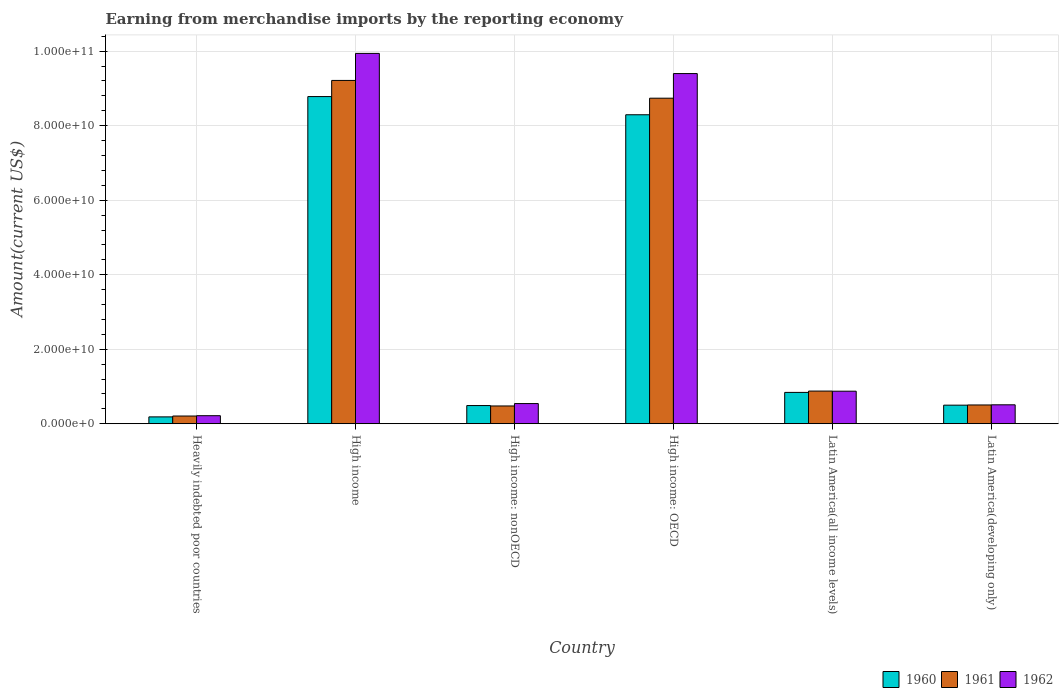How many different coloured bars are there?
Provide a succinct answer. 3. Are the number of bars per tick equal to the number of legend labels?
Offer a very short reply. Yes. Are the number of bars on each tick of the X-axis equal?
Your response must be concise. Yes. How many bars are there on the 5th tick from the right?
Your answer should be compact. 3. What is the label of the 3rd group of bars from the left?
Offer a very short reply. High income: nonOECD. In how many cases, is the number of bars for a given country not equal to the number of legend labels?
Your answer should be very brief. 0. What is the amount earned from merchandise imports in 1960 in High income: nonOECD?
Offer a terse response. 4.88e+09. Across all countries, what is the maximum amount earned from merchandise imports in 1961?
Your answer should be compact. 9.21e+1. Across all countries, what is the minimum amount earned from merchandise imports in 1962?
Offer a very short reply. 2.16e+09. In which country was the amount earned from merchandise imports in 1961 maximum?
Your response must be concise. High income. In which country was the amount earned from merchandise imports in 1961 minimum?
Your response must be concise. Heavily indebted poor countries. What is the total amount earned from merchandise imports in 1961 in the graph?
Your answer should be very brief. 2.00e+11. What is the difference between the amount earned from merchandise imports in 1962 in High income and that in High income: OECD?
Your answer should be very brief. 5.41e+09. What is the difference between the amount earned from merchandise imports in 1962 in Latin America(developing only) and the amount earned from merchandise imports in 1960 in High income: OECD?
Your answer should be compact. -7.78e+1. What is the average amount earned from merchandise imports in 1962 per country?
Your answer should be compact. 3.58e+1. What is the difference between the amount earned from merchandise imports of/in 1961 and amount earned from merchandise imports of/in 1960 in High income?
Offer a very short reply. 4.34e+09. In how many countries, is the amount earned from merchandise imports in 1960 greater than 28000000000 US$?
Your answer should be compact. 2. What is the ratio of the amount earned from merchandise imports in 1961 in High income to that in High income: OECD?
Your answer should be very brief. 1.05. Is the amount earned from merchandise imports in 1960 in High income less than that in High income: nonOECD?
Make the answer very short. No. Is the difference between the amount earned from merchandise imports in 1961 in Heavily indebted poor countries and High income: nonOECD greater than the difference between the amount earned from merchandise imports in 1960 in Heavily indebted poor countries and High income: nonOECD?
Offer a very short reply. Yes. What is the difference between the highest and the second highest amount earned from merchandise imports in 1961?
Keep it short and to the point. 8.34e+1. What is the difference between the highest and the lowest amount earned from merchandise imports in 1960?
Make the answer very short. 8.60e+1. In how many countries, is the amount earned from merchandise imports in 1962 greater than the average amount earned from merchandise imports in 1962 taken over all countries?
Provide a succinct answer. 2. Is the sum of the amount earned from merchandise imports in 1961 in High income and Latin America(all income levels) greater than the maximum amount earned from merchandise imports in 1962 across all countries?
Make the answer very short. Yes. What does the 2nd bar from the right in High income represents?
Your answer should be compact. 1961. Is it the case that in every country, the sum of the amount earned from merchandise imports in 1961 and amount earned from merchandise imports in 1962 is greater than the amount earned from merchandise imports in 1960?
Your response must be concise. Yes. How many bars are there?
Offer a very short reply. 18. What is the difference between two consecutive major ticks on the Y-axis?
Provide a succinct answer. 2.00e+1. Does the graph contain any zero values?
Your answer should be compact. No. What is the title of the graph?
Your response must be concise. Earning from merchandise imports by the reporting economy. Does "1997" appear as one of the legend labels in the graph?
Keep it short and to the point. No. What is the label or title of the X-axis?
Provide a succinct answer. Country. What is the label or title of the Y-axis?
Give a very brief answer. Amount(current US$). What is the Amount(current US$) of 1960 in Heavily indebted poor countries?
Offer a terse response. 1.84e+09. What is the Amount(current US$) of 1961 in Heavily indebted poor countries?
Your answer should be compact. 2.07e+09. What is the Amount(current US$) in 1962 in Heavily indebted poor countries?
Provide a succinct answer. 2.16e+09. What is the Amount(current US$) of 1960 in High income?
Keep it short and to the point. 8.78e+1. What is the Amount(current US$) in 1961 in High income?
Keep it short and to the point. 9.21e+1. What is the Amount(current US$) of 1962 in High income?
Offer a very short reply. 9.94e+1. What is the Amount(current US$) of 1960 in High income: nonOECD?
Your answer should be compact. 4.88e+09. What is the Amount(current US$) in 1961 in High income: nonOECD?
Offer a terse response. 4.77e+09. What is the Amount(current US$) of 1962 in High income: nonOECD?
Offer a very short reply. 5.41e+09. What is the Amount(current US$) in 1960 in High income: OECD?
Your answer should be very brief. 8.29e+1. What is the Amount(current US$) of 1961 in High income: OECD?
Ensure brevity in your answer.  8.74e+1. What is the Amount(current US$) of 1962 in High income: OECD?
Your answer should be very brief. 9.40e+1. What is the Amount(current US$) in 1960 in Latin America(all income levels)?
Your answer should be compact. 8.41e+09. What is the Amount(current US$) in 1961 in Latin America(all income levels)?
Your response must be concise. 8.77e+09. What is the Amount(current US$) of 1962 in Latin America(all income levels)?
Your response must be concise. 8.73e+09. What is the Amount(current US$) of 1960 in Latin America(developing only)?
Ensure brevity in your answer.  4.99e+09. What is the Amount(current US$) in 1961 in Latin America(developing only)?
Provide a short and direct response. 5.04e+09. What is the Amount(current US$) of 1962 in Latin America(developing only)?
Your response must be concise. 5.08e+09. Across all countries, what is the maximum Amount(current US$) in 1960?
Ensure brevity in your answer.  8.78e+1. Across all countries, what is the maximum Amount(current US$) of 1961?
Ensure brevity in your answer.  9.21e+1. Across all countries, what is the maximum Amount(current US$) of 1962?
Your response must be concise. 9.94e+1. Across all countries, what is the minimum Amount(current US$) in 1960?
Provide a short and direct response. 1.84e+09. Across all countries, what is the minimum Amount(current US$) in 1961?
Offer a very short reply. 2.07e+09. Across all countries, what is the minimum Amount(current US$) in 1962?
Provide a succinct answer. 2.16e+09. What is the total Amount(current US$) of 1960 in the graph?
Make the answer very short. 1.91e+11. What is the total Amount(current US$) in 1961 in the graph?
Provide a succinct answer. 2.00e+11. What is the total Amount(current US$) of 1962 in the graph?
Make the answer very short. 2.15e+11. What is the difference between the Amount(current US$) in 1960 in Heavily indebted poor countries and that in High income?
Ensure brevity in your answer.  -8.60e+1. What is the difference between the Amount(current US$) of 1961 in Heavily indebted poor countries and that in High income?
Your response must be concise. -9.01e+1. What is the difference between the Amount(current US$) in 1962 in Heavily indebted poor countries and that in High income?
Provide a succinct answer. -9.72e+1. What is the difference between the Amount(current US$) in 1960 in Heavily indebted poor countries and that in High income: nonOECD?
Ensure brevity in your answer.  -3.04e+09. What is the difference between the Amount(current US$) of 1961 in Heavily indebted poor countries and that in High income: nonOECD?
Ensure brevity in your answer.  -2.70e+09. What is the difference between the Amount(current US$) in 1962 in Heavily indebted poor countries and that in High income: nonOECD?
Ensure brevity in your answer.  -3.25e+09. What is the difference between the Amount(current US$) in 1960 in Heavily indebted poor countries and that in High income: OECD?
Provide a succinct answer. -8.11e+1. What is the difference between the Amount(current US$) in 1961 in Heavily indebted poor countries and that in High income: OECD?
Give a very brief answer. -8.53e+1. What is the difference between the Amount(current US$) of 1962 in Heavily indebted poor countries and that in High income: OECD?
Keep it short and to the point. -9.18e+1. What is the difference between the Amount(current US$) of 1960 in Heavily indebted poor countries and that in Latin America(all income levels)?
Your answer should be very brief. -6.57e+09. What is the difference between the Amount(current US$) of 1961 in Heavily indebted poor countries and that in Latin America(all income levels)?
Your answer should be compact. -6.70e+09. What is the difference between the Amount(current US$) in 1962 in Heavily indebted poor countries and that in Latin America(all income levels)?
Keep it short and to the point. -6.57e+09. What is the difference between the Amount(current US$) in 1960 in Heavily indebted poor countries and that in Latin America(developing only)?
Ensure brevity in your answer.  -3.15e+09. What is the difference between the Amount(current US$) of 1961 in Heavily indebted poor countries and that in Latin America(developing only)?
Make the answer very short. -2.97e+09. What is the difference between the Amount(current US$) of 1962 in Heavily indebted poor countries and that in Latin America(developing only)?
Keep it short and to the point. -2.92e+09. What is the difference between the Amount(current US$) in 1960 in High income and that in High income: nonOECD?
Your response must be concise. 8.29e+1. What is the difference between the Amount(current US$) of 1961 in High income and that in High income: nonOECD?
Your response must be concise. 8.74e+1. What is the difference between the Amount(current US$) of 1962 in High income and that in High income: nonOECD?
Provide a succinct answer. 9.40e+1. What is the difference between the Amount(current US$) in 1960 in High income and that in High income: OECD?
Give a very brief answer. 4.88e+09. What is the difference between the Amount(current US$) of 1961 in High income and that in High income: OECD?
Offer a terse response. 4.77e+09. What is the difference between the Amount(current US$) of 1962 in High income and that in High income: OECD?
Keep it short and to the point. 5.41e+09. What is the difference between the Amount(current US$) in 1960 in High income and that in Latin America(all income levels)?
Offer a very short reply. 7.94e+1. What is the difference between the Amount(current US$) in 1961 in High income and that in Latin America(all income levels)?
Offer a very short reply. 8.34e+1. What is the difference between the Amount(current US$) in 1962 in High income and that in Latin America(all income levels)?
Make the answer very short. 9.07e+1. What is the difference between the Amount(current US$) in 1960 in High income and that in Latin America(developing only)?
Give a very brief answer. 8.28e+1. What is the difference between the Amount(current US$) in 1961 in High income and that in Latin America(developing only)?
Your answer should be very brief. 8.71e+1. What is the difference between the Amount(current US$) of 1962 in High income and that in Latin America(developing only)?
Provide a short and direct response. 9.43e+1. What is the difference between the Amount(current US$) in 1960 in High income: nonOECD and that in High income: OECD?
Make the answer very short. -7.80e+1. What is the difference between the Amount(current US$) in 1961 in High income: nonOECD and that in High income: OECD?
Offer a very short reply. -8.26e+1. What is the difference between the Amount(current US$) of 1962 in High income: nonOECD and that in High income: OECD?
Your answer should be very brief. -8.86e+1. What is the difference between the Amount(current US$) in 1960 in High income: nonOECD and that in Latin America(all income levels)?
Your answer should be very brief. -3.53e+09. What is the difference between the Amount(current US$) in 1961 in High income: nonOECD and that in Latin America(all income levels)?
Offer a terse response. -4.00e+09. What is the difference between the Amount(current US$) in 1962 in High income: nonOECD and that in Latin America(all income levels)?
Give a very brief answer. -3.32e+09. What is the difference between the Amount(current US$) in 1960 in High income: nonOECD and that in Latin America(developing only)?
Provide a short and direct response. -1.05e+08. What is the difference between the Amount(current US$) of 1961 in High income: nonOECD and that in Latin America(developing only)?
Your answer should be compact. -2.67e+08. What is the difference between the Amount(current US$) in 1962 in High income: nonOECD and that in Latin America(developing only)?
Your answer should be compact. 3.33e+08. What is the difference between the Amount(current US$) of 1960 in High income: OECD and that in Latin America(all income levels)?
Offer a terse response. 7.45e+1. What is the difference between the Amount(current US$) in 1961 in High income: OECD and that in Latin America(all income levels)?
Offer a terse response. 7.86e+1. What is the difference between the Amount(current US$) of 1962 in High income: OECD and that in Latin America(all income levels)?
Offer a very short reply. 8.53e+1. What is the difference between the Amount(current US$) of 1960 in High income: OECD and that in Latin America(developing only)?
Offer a very short reply. 7.79e+1. What is the difference between the Amount(current US$) of 1961 in High income: OECD and that in Latin America(developing only)?
Provide a short and direct response. 8.23e+1. What is the difference between the Amount(current US$) in 1962 in High income: OECD and that in Latin America(developing only)?
Keep it short and to the point. 8.89e+1. What is the difference between the Amount(current US$) in 1960 in Latin America(all income levels) and that in Latin America(developing only)?
Provide a succinct answer. 3.42e+09. What is the difference between the Amount(current US$) of 1961 in Latin America(all income levels) and that in Latin America(developing only)?
Offer a very short reply. 3.73e+09. What is the difference between the Amount(current US$) of 1962 in Latin America(all income levels) and that in Latin America(developing only)?
Make the answer very short. 3.65e+09. What is the difference between the Amount(current US$) in 1960 in Heavily indebted poor countries and the Amount(current US$) in 1961 in High income?
Offer a very short reply. -9.03e+1. What is the difference between the Amount(current US$) in 1960 in Heavily indebted poor countries and the Amount(current US$) in 1962 in High income?
Keep it short and to the point. -9.76e+1. What is the difference between the Amount(current US$) in 1961 in Heavily indebted poor countries and the Amount(current US$) in 1962 in High income?
Provide a short and direct response. -9.73e+1. What is the difference between the Amount(current US$) of 1960 in Heavily indebted poor countries and the Amount(current US$) of 1961 in High income: nonOECD?
Give a very brief answer. -2.93e+09. What is the difference between the Amount(current US$) in 1960 in Heavily indebted poor countries and the Amount(current US$) in 1962 in High income: nonOECD?
Keep it short and to the point. -3.57e+09. What is the difference between the Amount(current US$) in 1961 in Heavily indebted poor countries and the Amount(current US$) in 1962 in High income: nonOECD?
Your answer should be compact. -3.34e+09. What is the difference between the Amount(current US$) of 1960 in Heavily indebted poor countries and the Amount(current US$) of 1961 in High income: OECD?
Keep it short and to the point. -8.55e+1. What is the difference between the Amount(current US$) of 1960 in Heavily indebted poor countries and the Amount(current US$) of 1962 in High income: OECD?
Ensure brevity in your answer.  -9.21e+1. What is the difference between the Amount(current US$) of 1961 in Heavily indebted poor countries and the Amount(current US$) of 1962 in High income: OECD?
Your response must be concise. -9.19e+1. What is the difference between the Amount(current US$) of 1960 in Heavily indebted poor countries and the Amount(current US$) of 1961 in Latin America(all income levels)?
Keep it short and to the point. -6.93e+09. What is the difference between the Amount(current US$) in 1960 in Heavily indebted poor countries and the Amount(current US$) in 1962 in Latin America(all income levels)?
Ensure brevity in your answer.  -6.89e+09. What is the difference between the Amount(current US$) in 1961 in Heavily indebted poor countries and the Amount(current US$) in 1962 in Latin America(all income levels)?
Your answer should be very brief. -6.66e+09. What is the difference between the Amount(current US$) of 1960 in Heavily indebted poor countries and the Amount(current US$) of 1961 in Latin America(developing only)?
Offer a terse response. -3.20e+09. What is the difference between the Amount(current US$) of 1960 in Heavily indebted poor countries and the Amount(current US$) of 1962 in Latin America(developing only)?
Your answer should be compact. -3.24e+09. What is the difference between the Amount(current US$) of 1961 in Heavily indebted poor countries and the Amount(current US$) of 1962 in Latin America(developing only)?
Make the answer very short. -3.01e+09. What is the difference between the Amount(current US$) in 1960 in High income and the Amount(current US$) in 1961 in High income: nonOECD?
Your answer should be compact. 8.30e+1. What is the difference between the Amount(current US$) in 1960 in High income and the Amount(current US$) in 1962 in High income: nonOECD?
Offer a terse response. 8.24e+1. What is the difference between the Amount(current US$) of 1961 in High income and the Amount(current US$) of 1962 in High income: nonOECD?
Give a very brief answer. 8.67e+1. What is the difference between the Amount(current US$) of 1960 in High income and the Amount(current US$) of 1961 in High income: OECD?
Make the answer very short. 4.36e+08. What is the difference between the Amount(current US$) of 1960 in High income and the Amount(current US$) of 1962 in High income: OECD?
Offer a very short reply. -6.18e+09. What is the difference between the Amount(current US$) in 1961 in High income and the Amount(current US$) in 1962 in High income: OECD?
Keep it short and to the point. -1.84e+09. What is the difference between the Amount(current US$) of 1960 in High income and the Amount(current US$) of 1961 in Latin America(all income levels)?
Your answer should be very brief. 7.90e+1. What is the difference between the Amount(current US$) in 1960 in High income and the Amount(current US$) in 1962 in Latin America(all income levels)?
Give a very brief answer. 7.91e+1. What is the difference between the Amount(current US$) in 1961 in High income and the Amount(current US$) in 1962 in Latin America(all income levels)?
Your response must be concise. 8.34e+1. What is the difference between the Amount(current US$) in 1960 in High income and the Amount(current US$) in 1961 in Latin America(developing only)?
Offer a terse response. 8.28e+1. What is the difference between the Amount(current US$) of 1960 in High income and the Amount(current US$) of 1962 in Latin America(developing only)?
Ensure brevity in your answer.  8.27e+1. What is the difference between the Amount(current US$) of 1961 in High income and the Amount(current US$) of 1962 in Latin America(developing only)?
Offer a terse response. 8.71e+1. What is the difference between the Amount(current US$) in 1960 in High income: nonOECD and the Amount(current US$) in 1961 in High income: OECD?
Offer a terse response. -8.25e+1. What is the difference between the Amount(current US$) of 1960 in High income: nonOECD and the Amount(current US$) of 1962 in High income: OECD?
Offer a terse response. -8.91e+1. What is the difference between the Amount(current US$) of 1961 in High income: nonOECD and the Amount(current US$) of 1962 in High income: OECD?
Your answer should be very brief. -8.92e+1. What is the difference between the Amount(current US$) in 1960 in High income: nonOECD and the Amount(current US$) in 1961 in Latin America(all income levels)?
Ensure brevity in your answer.  -3.89e+09. What is the difference between the Amount(current US$) in 1960 in High income: nonOECD and the Amount(current US$) in 1962 in Latin America(all income levels)?
Your answer should be very brief. -3.85e+09. What is the difference between the Amount(current US$) in 1961 in High income: nonOECD and the Amount(current US$) in 1962 in Latin America(all income levels)?
Offer a terse response. -3.96e+09. What is the difference between the Amount(current US$) of 1960 in High income: nonOECD and the Amount(current US$) of 1961 in Latin America(developing only)?
Provide a succinct answer. -1.57e+08. What is the difference between the Amount(current US$) of 1960 in High income: nonOECD and the Amount(current US$) of 1962 in Latin America(developing only)?
Keep it short and to the point. -2.00e+08. What is the difference between the Amount(current US$) in 1961 in High income: nonOECD and the Amount(current US$) in 1962 in Latin America(developing only)?
Provide a succinct answer. -3.11e+08. What is the difference between the Amount(current US$) of 1960 in High income: OECD and the Amount(current US$) of 1961 in Latin America(all income levels)?
Ensure brevity in your answer.  7.42e+1. What is the difference between the Amount(current US$) of 1960 in High income: OECD and the Amount(current US$) of 1962 in Latin America(all income levels)?
Your answer should be very brief. 7.42e+1. What is the difference between the Amount(current US$) of 1961 in High income: OECD and the Amount(current US$) of 1962 in Latin America(all income levels)?
Give a very brief answer. 7.86e+1. What is the difference between the Amount(current US$) in 1960 in High income: OECD and the Amount(current US$) in 1961 in Latin America(developing only)?
Ensure brevity in your answer.  7.79e+1. What is the difference between the Amount(current US$) in 1960 in High income: OECD and the Amount(current US$) in 1962 in Latin America(developing only)?
Your response must be concise. 7.78e+1. What is the difference between the Amount(current US$) of 1961 in High income: OECD and the Amount(current US$) of 1962 in Latin America(developing only)?
Ensure brevity in your answer.  8.23e+1. What is the difference between the Amount(current US$) in 1960 in Latin America(all income levels) and the Amount(current US$) in 1961 in Latin America(developing only)?
Offer a terse response. 3.37e+09. What is the difference between the Amount(current US$) in 1960 in Latin America(all income levels) and the Amount(current US$) in 1962 in Latin America(developing only)?
Make the answer very short. 3.33e+09. What is the difference between the Amount(current US$) of 1961 in Latin America(all income levels) and the Amount(current US$) of 1962 in Latin America(developing only)?
Ensure brevity in your answer.  3.69e+09. What is the average Amount(current US$) of 1960 per country?
Provide a short and direct response. 3.18e+1. What is the average Amount(current US$) in 1961 per country?
Provide a short and direct response. 3.34e+1. What is the average Amount(current US$) of 1962 per country?
Offer a very short reply. 3.58e+1. What is the difference between the Amount(current US$) of 1960 and Amount(current US$) of 1961 in Heavily indebted poor countries?
Ensure brevity in your answer.  -2.30e+08. What is the difference between the Amount(current US$) in 1960 and Amount(current US$) in 1962 in Heavily indebted poor countries?
Give a very brief answer. -3.19e+08. What is the difference between the Amount(current US$) of 1961 and Amount(current US$) of 1962 in Heavily indebted poor countries?
Provide a succinct answer. -8.88e+07. What is the difference between the Amount(current US$) of 1960 and Amount(current US$) of 1961 in High income?
Your response must be concise. -4.34e+09. What is the difference between the Amount(current US$) in 1960 and Amount(current US$) in 1962 in High income?
Provide a succinct answer. -1.16e+1. What is the difference between the Amount(current US$) of 1961 and Amount(current US$) of 1962 in High income?
Provide a succinct answer. -7.26e+09. What is the difference between the Amount(current US$) in 1960 and Amount(current US$) in 1961 in High income: nonOECD?
Your answer should be very brief. 1.11e+08. What is the difference between the Amount(current US$) of 1960 and Amount(current US$) of 1962 in High income: nonOECD?
Ensure brevity in your answer.  -5.33e+08. What is the difference between the Amount(current US$) in 1961 and Amount(current US$) in 1962 in High income: nonOECD?
Offer a terse response. -6.43e+08. What is the difference between the Amount(current US$) of 1960 and Amount(current US$) of 1961 in High income: OECD?
Offer a terse response. -4.45e+09. What is the difference between the Amount(current US$) in 1960 and Amount(current US$) in 1962 in High income: OECD?
Provide a short and direct response. -1.11e+1. What is the difference between the Amount(current US$) of 1961 and Amount(current US$) of 1962 in High income: OECD?
Give a very brief answer. -6.61e+09. What is the difference between the Amount(current US$) of 1960 and Amount(current US$) of 1961 in Latin America(all income levels)?
Offer a very short reply. -3.57e+08. What is the difference between the Amount(current US$) in 1960 and Amount(current US$) in 1962 in Latin America(all income levels)?
Ensure brevity in your answer.  -3.21e+08. What is the difference between the Amount(current US$) in 1961 and Amount(current US$) in 1962 in Latin America(all income levels)?
Make the answer very short. 3.56e+07. What is the difference between the Amount(current US$) of 1960 and Amount(current US$) of 1961 in Latin America(developing only)?
Provide a succinct answer. -5.12e+07. What is the difference between the Amount(current US$) of 1960 and Amount(current US$) of 1962 in Latin America(developing only)?
Keep it short and to the point. -9.45e+07. What is the difference between the Amount(current US$) of 1961 and Amount(current US$) of 1962 in Latin America(developing only)?
Offer a very short reply. -4.34e+07. What is the ratio of the Amount(current US$) of 1960 in Heavily indebted poor countries to that in High income?
Give a very brief answer. 0.02. What is the ratio of the Amount(current US$) in 1961 in Heavily indebted poor countries to that in High income?
Your response must be concise. 0.02. What is the ratio of the Amount(current US$) of 1962 in Heavily indebted poor countries to that in High income?
Your answer should be very brief. 0.02. What is the ratio of the Amount(current US$) in 1960 in Heavily indebted poor countries to that in High income: nonOECD?
Provide a short and direct response. 0.38. What is the ratio of the Amount(current US$) of 1961 in Heavily indebted poor countries to that in High income: nonOECD?
Provide a succinct answer. 0.43. What is the ratio of the Amount(current US$) of 1962 in Heavily indebted poor countries to that in High income: nonOECD?
Make the answer very short. 0.4. What is the ratio of the Amount(current US$) of 1960 in Heavily indebted poor countries to that in High income: OECD?
Offer a very short reply. 0.02. What is the ratio of the Amount(current US$) of 1961 in Heavily indebted poor countries to that in High income: OECD?
Ensure brevity in your answer.  0.02. What is the ratio of the Amount(current US$) in 1962 in Heavily indebted poor countries to that in High income: OECD?
Make the answer very short. 0.02. What is the ratio of the Amount(current US$) of 1960 in Heavily indebted poor countries to that in Latin America(all income levels)?
Offer a very short reply. 0.22. What is the ratio of the Amount(current US$) in 1961 in Heavily indebted poor countries to that in Latin America(all income levels)?
Your answer should be compact. 0.24. What is the ratio of the Amount(current US$) of 1962 in Heavily indebted poor countries to that in Latin America(all income levels)?
Your answer should be compact. 0.25. What is the ratio of the Amount(current US$) in 1960 in Heavily indebted poor countries to that in Latin America(developing only)?
Ensure brevity in your answer.  0.37. What is the ratio of the Amount(current US$) of 1961 in Heavily indebted poor countries to that in Latin America(developing only)?
Keep it short and to the point. 0.41. What is the ratio of the Amount(current US$) in 1962 in Heavily indebted poor countries to that in Latin America(developing only)?
Provide a succinct answer. 0.43. What is the ratio of the Amount(current US$) of 1960 in High income to that in High income: nonOECD?
Your answer should be very brief. 17.99. What is the ratio of the Amount(current US$) in 1961 in High income to that in High income: nonOECD?
Keep it short and to the point. 19.31. What is the ratio of the Amount(current US$) of 1962 in High income to that in High income: nonOECD?
Keep it short and to the point. 18.36. What is the ratio of the Amount(current US$) of 1960 in High income to that in High income: OECD?
Make the answer very short. 1.06. What is the ratio of the Amount(current US$) in 1961 in High income to that in High income: OECD?
Your answer should be very brief. 1.05. What is the ratio of the Amount(current US$) in 1962 in High income to that in High income: OECD?
Offer a very short reply. 1.06. What is the ratio of the Amount(current US$) in 1960 in High income to that in Latin America(all income levels)?
Your answer should be very brief. 10.44. What is the ratio of the Amount(current US$) of 1961 in High income to that in Latin America(all income levels)?
Ensure brevity in your answer.  10.51. What is the ratio of the Amount(current US$) of 1962 in High income to that in Latin America(all income levels)?
Offer a terse response. 11.38. What is the ratio of the Amount(current US$) in 1960 in High income to that in Latin America(developing only)?
Your answer should be very brief. 17.61. What is the ratio of the Amount(current US$) in 1961 in High income to that in Latin America(developing only)?
Make the answer very short. 18.29. What is the ratio of the Amount(current US$) of 1962 in High income to that in Latin America(developing only)?
Provide a succinct answer. 19.56. What is the ratio of the Amount(current US$) in 1960 in High income: nonOECD to that in High income: OECD?
Make the answer very short. 0.06. What is the ratio of the Amount(current US$) of 1961 in High income: nonOECD to that in High income: OECD?
Ensure brevity in your answer.  0.05. What is the ratio of the Amount(current US$) of 1962 in High income: nonOECD to that in High income: OECD?
Make the answer very short. 0.06. What is the ratio of the Amount(current US$) in 1960 in High income: nonOECD to that in Latin America(all income levels)?
Offer a very short reply. 0.58. What is the ratio of the Amount(current US$) in 1961 in High income: nonOECD to that in Latin America(all income levels)?
Ensure brevity in your answer.  0.54. What is the ratio of the Amount(current US$) of 1962 in High income: nonOECD to that in Latin America(all income levels)?
Provide a succinct answer. 0.62. What is the ratio of the Amount(current US$) in 1960 in High income: nonOECD to that in Latin America(developing only)?
Ensure brevity in your answer.  0.98. What is the ratio of the Amount(current US$) of 1961 in High income: nonOECD to that in Latin America(developing only)?
Provide a short and direct response. 0.95. What is the ratio of the Amount(current US$) in 1962 in High income: nonOECD to that in Latin America(developing only)?
Your answer should be very brief. 1.07. What is the ratio of the Amount(current US$) of 1960 in High income: OECD to that in Latin America(all income levels)?
Provide a succinct answer. 9.86. What is the ratio of the Amount(current US$) in 1961 in High income: OECD to that in Latin America(all income levels)?
Give a very brief answer. 9.96. What is the ratio of the Amount(current US$) in 1962 in High income: OECD to that in Latin America(all income levels)?
Give a very brief answer. 10.76. What is the ratio of the Amount(current US$) in 1960 in High income: OECD to that in Latin America(developing only)?
Your answer should be compact. 16.63. What is the ratio of the Amount(current US$) in 1961 in High income: OECD to that in Latin America(developing only)?
Give a very brief answer. 17.34. What is the ratio of the Amount(current US$) of 1962 in High income: OECD to that in Latin America(developing only)?
Provide a succinct answer. 18.49. What is the ratio of the Amount(current US$) of 1960 in Latin America(all income levels) to that in Latin America(developing only)?
Offer a very short reply. 1.69. What is the ratio of the Amount(current US$) in 1961 in Latin America(all income levels) to that in Latin America(developing only)?
Provide a succinct answer. 1.74. What is the ratio of the Amount(current US$) of 1962 in Latin America(all income levels) to that in Latin America(developing only)?
Your response must be concise. 1.72. What is the difference between the highest and the second highest Amount(current US$) in 1960?
Your answer should be compact. 4.88e+09. What is the difference between the highest and the second highest Amount(current US$) of 1961?
Your answer should be very brief. 4.77e+09. What is the difference between the highest and the second highest Amount(current US$) of 1962?
Your answer should be compact. 5.41e+09. What is the difference between the highest and the lowest Amount(current US$) in 1960?
Keep it short and to the point. 8.60e+1. What is the difference between the highest and the lowest Amount(current US$) of 1961?
Offer a terse response. 9.01e+1. What is the difference between the highest and the lowest Amount(current US$) in 1962?
Offer a terse response. 9.72e+1. 